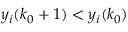<formula> <loc_0><loc_0><loc_500><loc_500>y _ { i } ( k _ { 0 } + 1 ) < y _ { i } ( k _ { 0 } )</formula> 